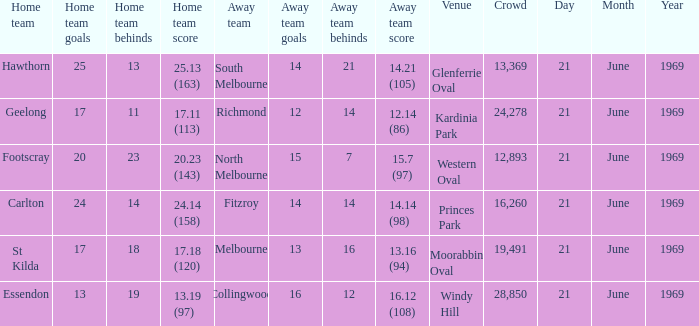When did an away team score 15.7 (97)? 21 June 1969. 